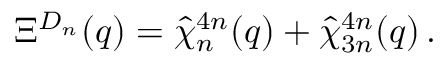Convert formula to latex. <formula><loc_0><loc_0><loc_500><loc_500>\Xi ^ { D _ { n } } ( q ) = \hat { \chi } _ { n } ^ { 4 n } ( q ) + \hat { \chi } _ { 3 n } ^ { 4 n } ( q ) \, .</formula> 